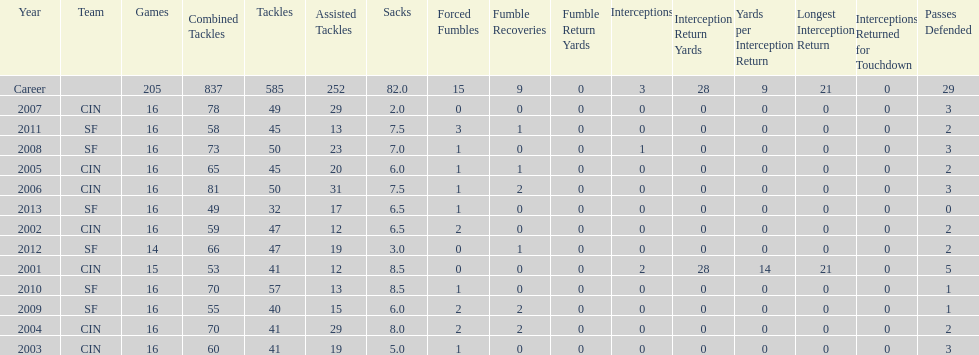How many sacks did this player have in his first five seasons? 34. 